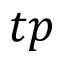<formula> <loc_0><loc_0><loc_500><loc_500>t p</formula> 